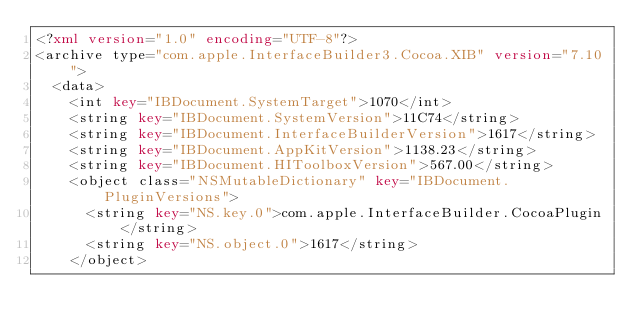Convert code to text. <code><loc_0><loc_0><loc_500><loc_500><_XML_><?xml version="1.0" encoding="UTF-8"?>
<archive type="com.apple.InterfaceBuilder3.Cocoa.XIB" version="7.10">
	<data>
		<int key="IBDocument.SystemTarget">1070</int>
		<string key="IBDocument.SystemVersion">11C74</string>
		<string key="IBDocument.InterfaceBuilderVersion">1617</string>
		<string key="IBDocument.AppKitVersion">1138.23</string>
		<string key="IBDocument.HIToolboxVersion">567.00</string>
		<object class="NSMutableDictionary" key="IBDocument.PluginVersions">
			<string key="NS.key.0">com.apple.InterfaceBuilder.CocoaPlugin</string>
			<string key="NS.object.0">1617</string>
		</object></code> 